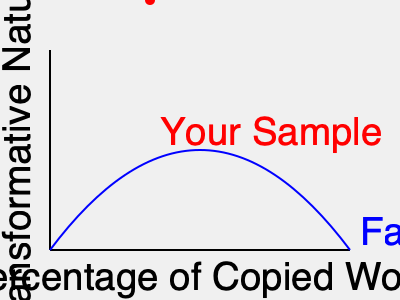Based on the graph illustrating the relationship between the percentage of copied work and transformative nature in fair use cases, where does your sampled work fall in relation to the fair use threshold? How might this impact your legal defense against copyright infringement accusations? To analyze the legal threshold for fair use based on the graph:

1. Understand the axes:
   - X-axis represents the percentage of copied work
   - Y-axis represents the transformative nature of the new work

2. Interpret the blue curve:
   - This represents the fair use threshold
   - Points above the curve are more likely to be considered fair use
   - Points below the curve are less likely to be considered fair use

3. Locate your sample (red dot):
   - It appears to be close to the threshold line
   - Slightly above the curve, but not by a large margin

4. Analyze the position:
   - The sample uses a moderate amount of copied work (around 30-40%)
   - It has a moderate level of transformative nature

5. Consider legal implications:
   - Being slightly above the line suggests a potential fair use argument
   - However, the proximity to the line indicates it's not a clear-cut case

6. Develop a legal strategy:
   - Emphasize the transformative aspects of your work
   - Argue that the amount used was necessary for your artistic purpose
   - Prepare to demonstrate how your use doesn't negatively impact the original work's market

7. Consider risk factors:
   - The close proximity to the threshold means the case could go either way
   - Prepare for potential legal challenges and negotiations

In summary, while your sample appears to be just within the fair use territory, its position close to the threshold line suggests a nuanced legal situation that will require a strong argument focusing on the transformative nature of your work and the necessity of the sampling for your artistic expression.
Answer: Marginally fair use; requires strong legal argument emphasizing transformation and necessity. 